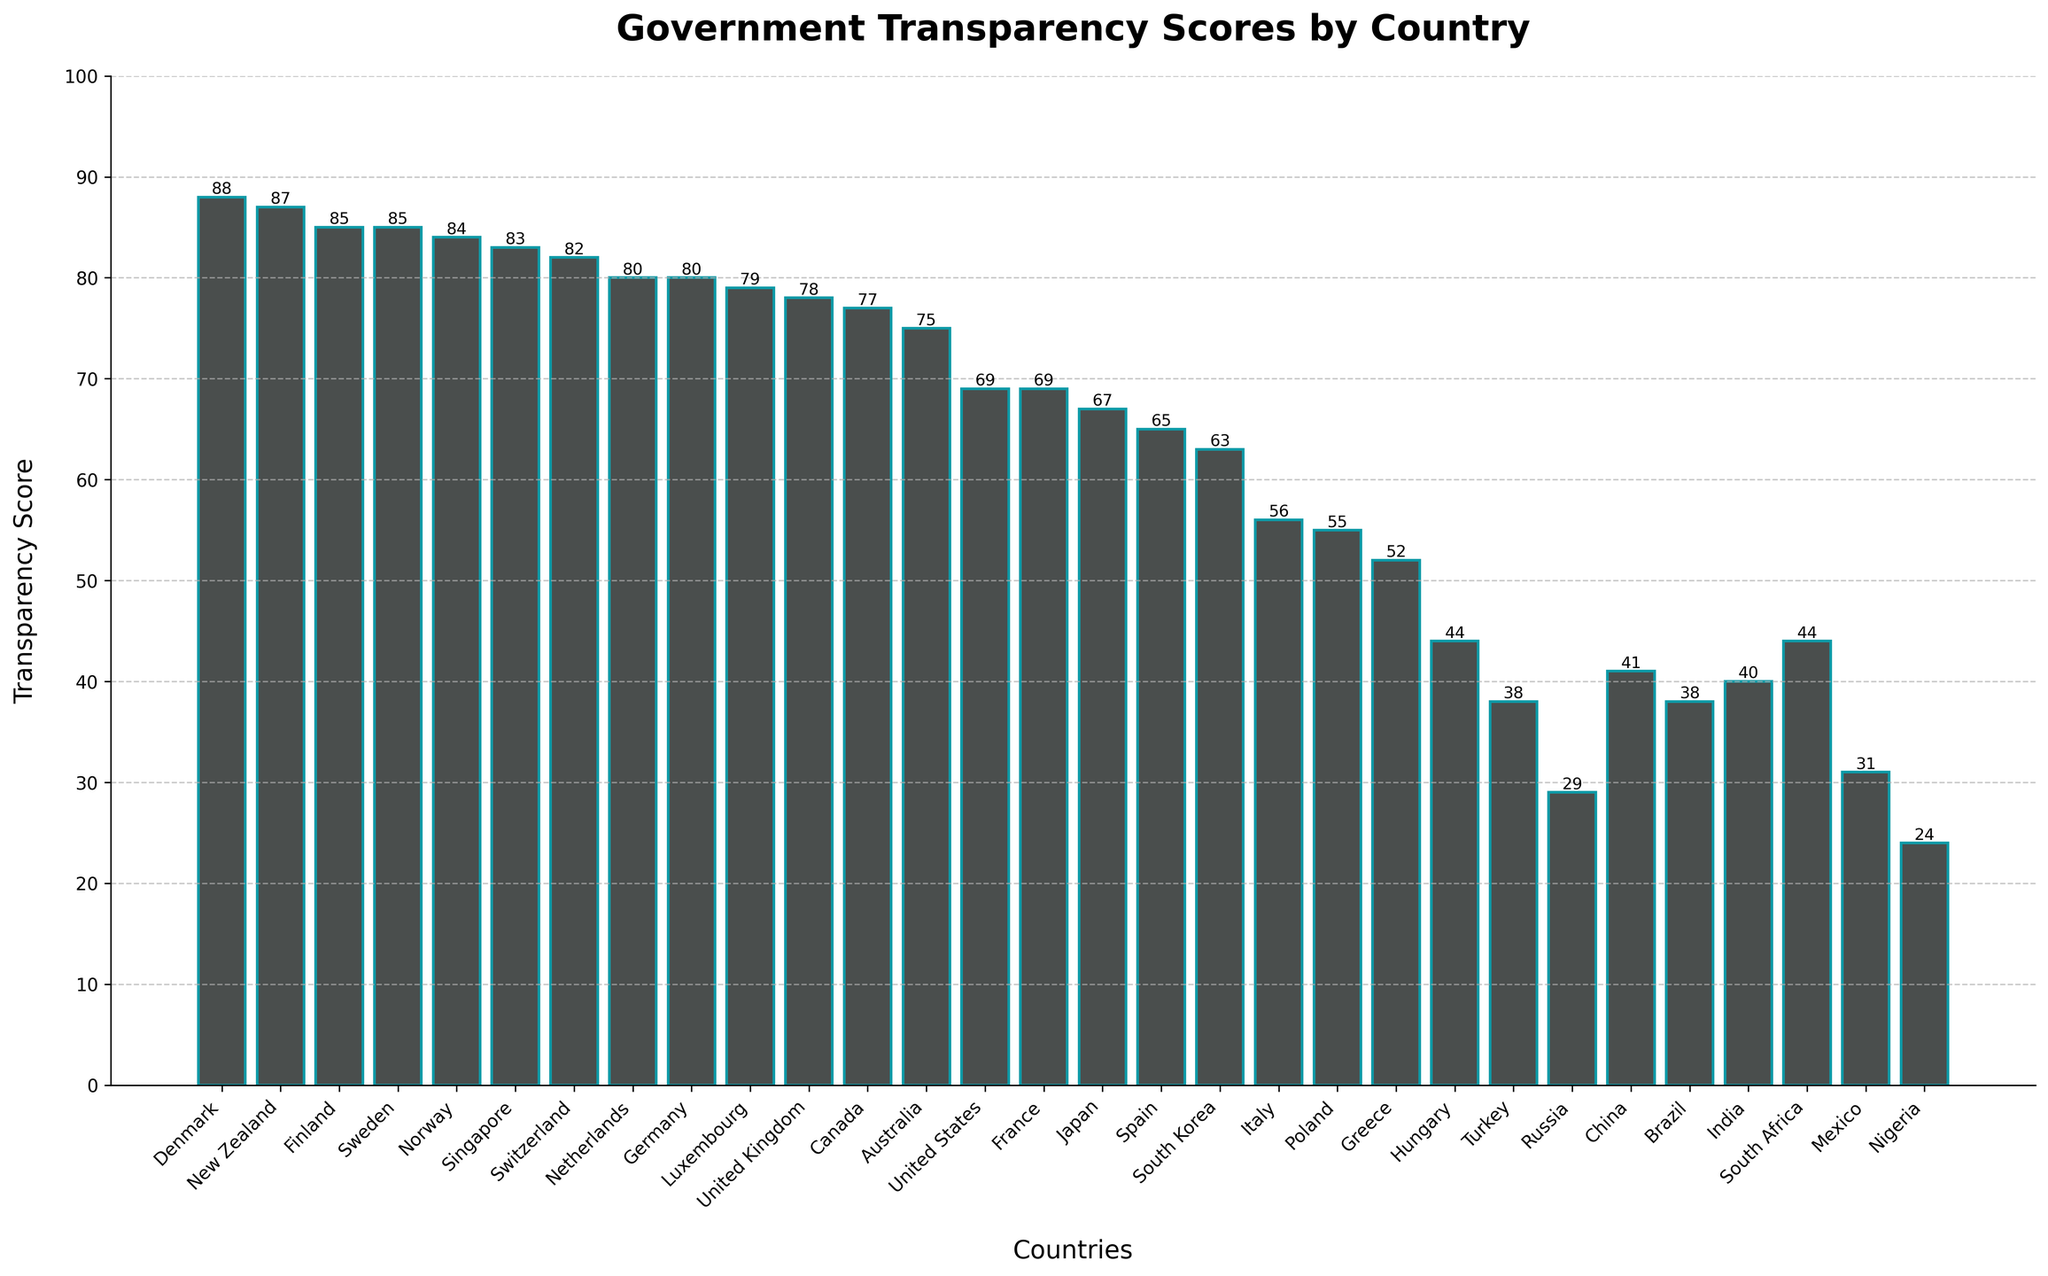Which country has the highest transparency score? The bar for Denmark is the tallest, indicating the highest transparency score.
Answer: Denmark Which countries have transparency scores higher than 80? The bars for Denmark, New Zealand, Finland, Sweden, Norway, Singapore, and Switzerland are above the 80 mark on the y-axis.
Answer: Denmark, New Zealand, Finland, Sweden, Norway, Singapore, Switzerland What is the difference in transparency scores between the United States and Canada? Locate the bars for the United States and Canada; Canada's bar is at 77 and the United States' bar is at 69. The difference is 77 - 69.
Answer: 8 Which country has a transparency score closest to 70? Look for the bar closest to the 70 mark. The United States and France score closest to 70, specifically scoring 69.
Answer: United States, France What is the average transparency score of Denmark, Finland, and Sweden? Find the bars for Denmark, Finland, and Sweden; their scores are 88, 85, and 85 respectively. Calculate the average: (88 + 85 + 85) / 3.
Answer: 86 Which country has the lowest transparency score? The bar for Nigeria is the shortest, indicating the lowest transparency score.
Answer: Nigeria How many countries have transparency scores below 50? Count the bars below the 50 mark: Hungary, Turkey, Russia, China, Brazil, Mexico, Nigeria.
Answer: 7 Which has a higher transparency score, Japan or Spain? Locate the bars for Japan and Spain. Japan scores 67, and Spain scores 65.
Answer: Japan What is the sum of transparency scores for Italy, Poland, and Greece? Find the bars for Italy, Poland, and Greece; their scores are 56, 55, and 52 respectively. Calculate the sum: 56 + 55 + 52.
Answer: 163 What is the median transparency score of the countries listed? Sort the scores and find the middle value. The scores are (24, 29, 31, 38, 38, 40, 41, 44, 44, 52, 55, 56, 63, 65, 67, 69, 69, 75, 77, 78, 79, 80, 80, 82, 83, 84, 85, 85, 87, 88). Since there are 30 countries, the median is the average of the 15th and 16th values: (69 + 69) / 2.
Answer: 69 